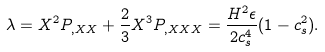Convert formula to latex. <formula><loc_0><loc_0><loc_500><loc_500>\lambda = X ^ { 2 } P _ { , X X } + \frac { 2 } { 3 } X ^ { 3 } P _ { , X X X } = \frac { H ^ { 2 } \epsilon } { 2 c _ { s } ^ { 4 } } ( 1 - c _ { s } ^ { 2 } ) .</formula> 